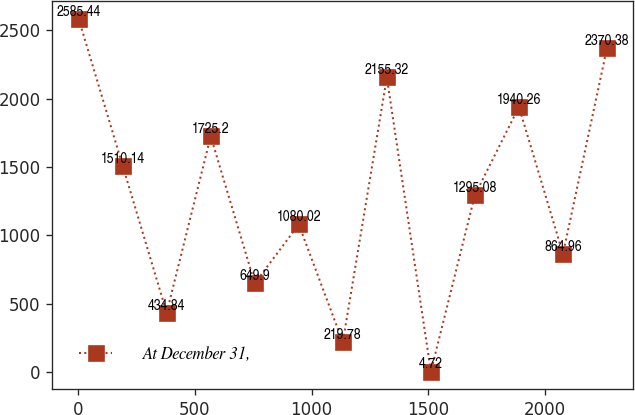Convert chart. <chart><loc_0><loc_0><loc_500><loc_500><line_chart><ecel><fcel>At December 31,<nl><fcel>2.17<fcel>2585.44<nl><fcel>190.72<fcel>1510.14<nl><fcel>379.27<fcel>434.84<nl><fcel>567.82<fcel>1725.2<nl><fcel>756.37<fcel>649.9<nl><fcel>944.92<fcel>1080.02<nl><fcel>1133.47<fcel>219.78<nl><fcel>1322.02<fcel>2155.32<nl><fcel>1510.57<fcel>4.72<nl><fcel>1699.12<fcel>1295.08<nl><fcel>1887.67<fcel>1940.26<nl><fcel>2076.22<fcel>864.96<nl><fcel>2264.77<fcel>2370.38<nl></chart> 